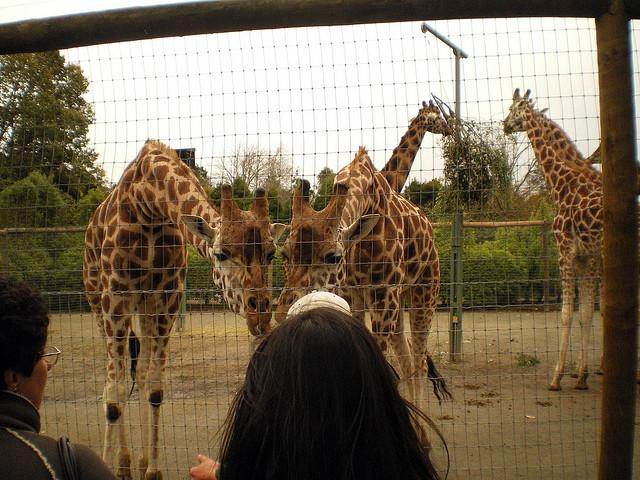What is the person on the left wearing? Please explain your reasoning. glasses. The person is question is identifiable by the text of the question and what they are wearing is visible. 